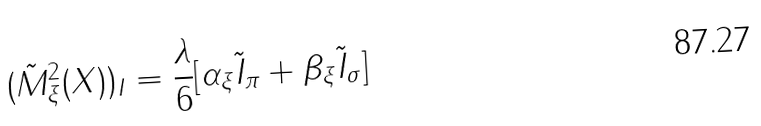<formula> <loc_0><loc_0><loc_500><loc_500>( \tilde { M } _ { \xi } ^ { 2 } ( X ) ) _ { I } = \frac { \lambda } { 6 } [ \alpha _ { \xi } \tilde { I } _ { \pi } + \beta _ { \xi } \tilde { I } _ { \sigma } ]</formula> 